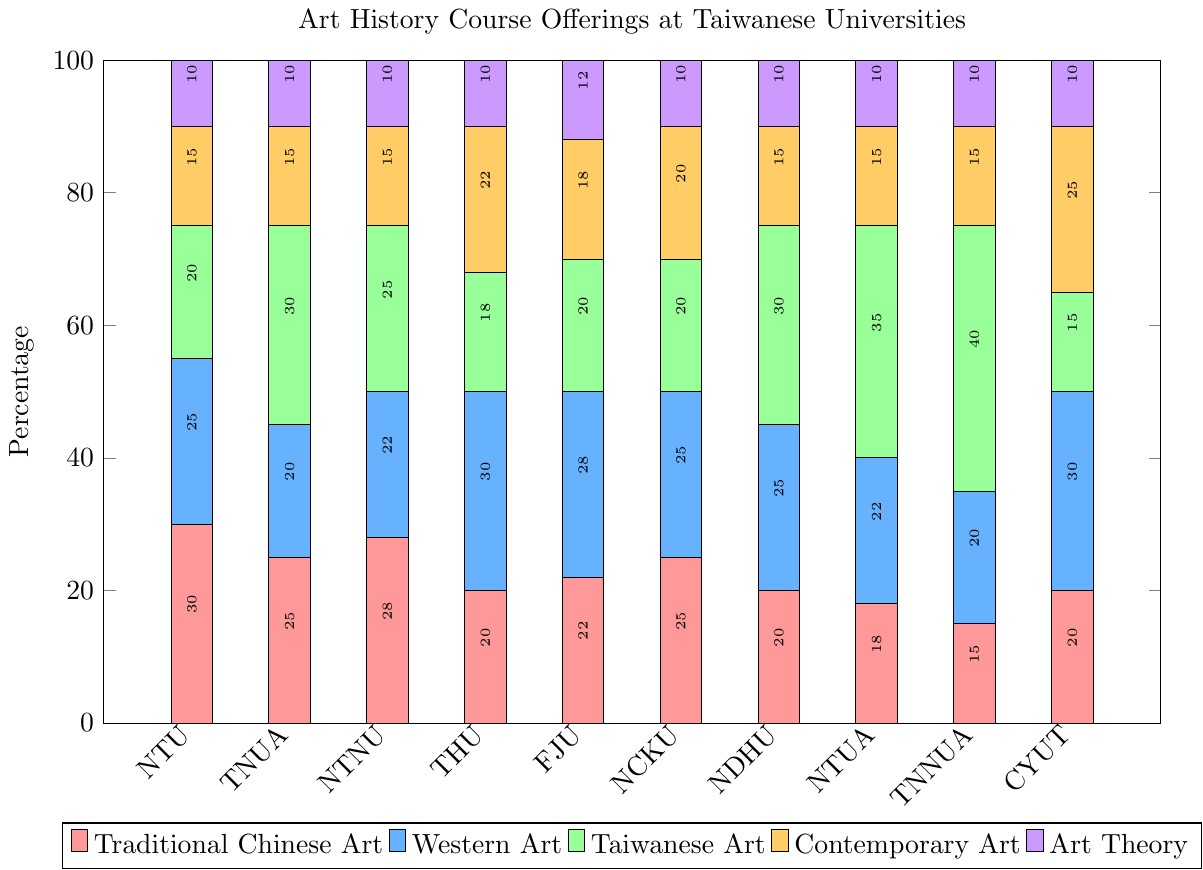Which university offers the highest percentage of Western Art courses? By looking at the plot, we see that the bar representing Western Art (colored blue) is tallest for Tunghai University and Chaoyang University of Technology.
Answer: Tunghai University and Chaoyang University of Technology Which university has the smallest percentage allocation for Traditional Chinese Art? By comparing the heights of the red bars for Traditional Chinese Art, we see that Tainan National University of the Arts has the shortest bar.
Answer: Tainan National University of the Arts How much higher is the percentage of Taiwanese Art courses at National Taiwan University of Arts compared to Fu Jen Catholic University? The height of the green bar for Taiwanese Art at National Taiwan University of Arts is 35%, while for Fu Jen Catholic University it is 20%. The difference is 35% - 20% = 15%.
Answer: 15% What is the total percentage of Traditional Chinese Art courses offered at National Taiwan University and National Cheng Kung University? The heights of the red bars for Traditional Chinese Art at National Taiwan University and National Cheng Kung University are 30% and 25%, respectively. Their sum is 30% + 25% = 55%.
Answer: 55% Which university has the highest total percentage of all art courses combined? We need to visually estimate the stacked bar heights. National Taiwan University of Arts appears to have the tallest stacked bar, indicating it has the highest total percentage of all art courses combined.
Answer: National Taiwan University of Arts Which universities allocate exactly 10% for Art Theory? By looking at the purple bars for Art Theory, we see that most of the universities have an equal height bar representing 10%: National Taiwan University, Taipei National University of the Arts, National Taiwan Normal University, Tunghai University, National Cheng Kung University, National Dong Hwa University, National Taiwan University of Arts, Tainan National University of the Arts, and Chaoyang University of Technology.
Answer: Nine universities How does the percentage of Contemporary Art courses at Tunghai University compare to that at National Taiwan University? The yellow bar for Contemporary Art at Tunghai University is taller (22%) compared to National Taiwan University (15%).
Answer: Higher at Tunghai University What is the average percentage of Taiwanese Art courses offered across all universities? Add the green bar values for Taiwanese Art courses at each university: 20 + 30 + 25 + 18 + 20 + 20 + 30 + 35 + 40 + 15 = 253. Divide by the number of universities: 253 / 10 = 25.3.
Answer: 25.3% Which category has the most consistent percentage values across all universities? By visually inspecting the bars for each category, Art Theory (purple) has the most consistent values across all universities, generally maintaining a 10% allocation with minor deviations.
Answer: Art Theory 